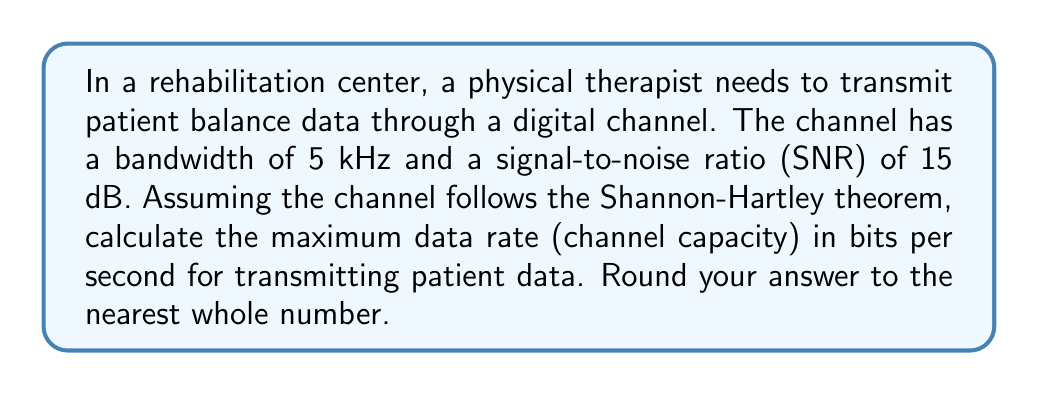Can you answer this question? To solve this problem, we'll use the Shannon-Hartley theorem, which is relevant to information theory and applicable in the context of transmitting patient data in a rehabilitation setting. The theorem states that the channel capacity $C$ is given by:

$$C = B \log_2(1 + SNR)$$

Where:
$C$ is the channel capacity in bits per second (bps)
$B$ is the bandwidth in Hz
$SNR$ is the signal-to-noise ratio (linear, not dB)

Given:
- Bandwidth ($B$) = 5 kHz = 5000 Hz
- SNR = 15 dB

Step 1: Convert SNR from dB to linear scale
$$SNR_{linear} = 10^{\frac{SNR_{dB}}{10}} = 10^{\frac{15}{10}} = 10^{1.5} \approx 31.6228$$

Step 2: Apply the Shannon-Hartley theorem
$$\begin{align}
C &= B \log_2(1 + SNR_{linear}) \\
&= 5000 \log_2(1 + 31.6228) \\
&= 5000 \log_2(32.6228) \\
&\approx 5000 \times 5.0279 \\
&\approx 25139.5 \text{ bps}
\end{align}$$

Step 3: Round to the nearest whole number
$$C \approx 25140 \text{ bps}$$

This result represents the maximum theoretical data rate at which the physical therapist can transmit patient balance data through the given channel without error, assuming optimal encoding.
Answer: 25140 bps 